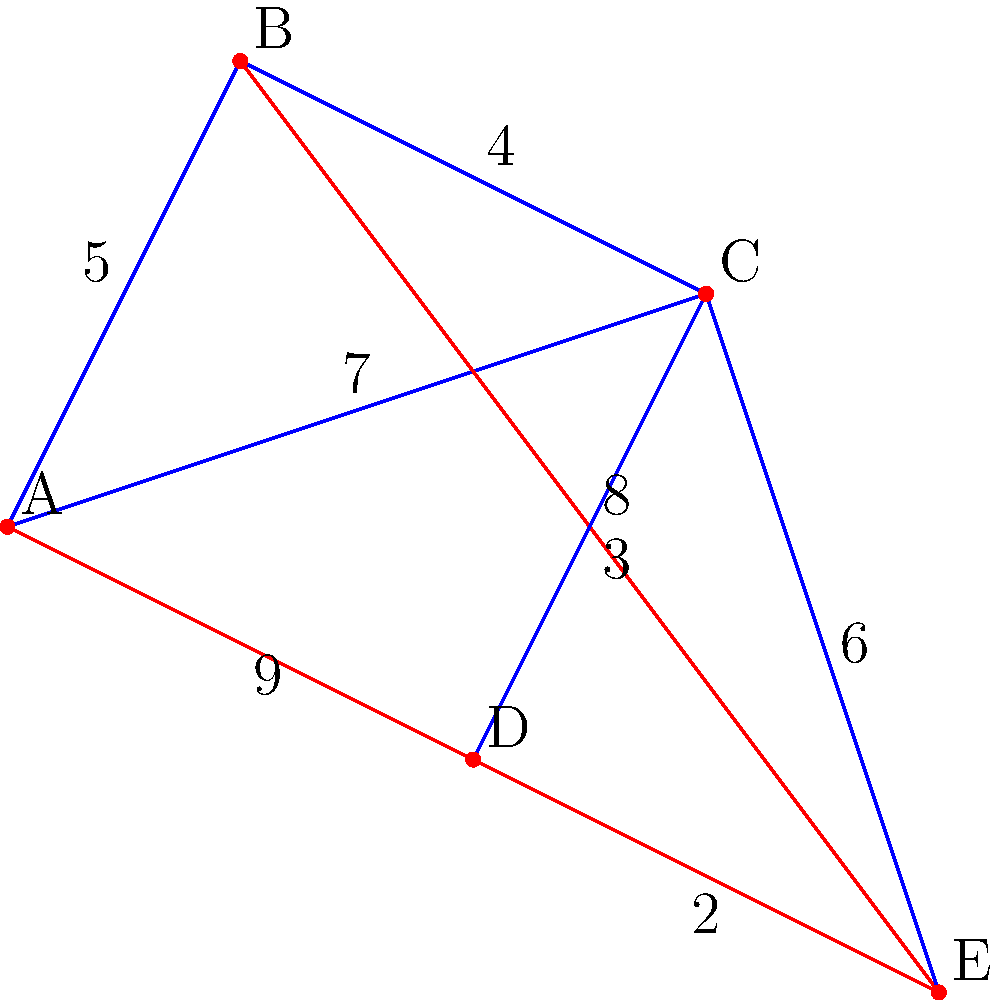In the given graph representing a hospital network, vertices represent different departments, and edges represent potential resource-sharing connections with associated costs. Using Kruskal's algorithm, determine the minimum spanning tree (MST) for optimizing resource allocation. What is the total cost of the MST? To find the minimum spanning tree using Kruskal's algorithm, we follow these steps:

1. Sort all edges by weight in ascending order:
   ED (2), CD (3), BC (4), AB (5), CE (6), AC (7), BE (8), AD (9)

2. Start with an empty set of edges and add edges in order if they don't create a cycle:
   - Add ED (2)
   - Add CD (3)
   - Add BC (4)
   - Add AB (5)

3. Stop when we have $n-1$ edges, where $n$ is the number of vertices.

The resulting minimum spanning tree consists of the edges:
1. ED (cost: 2)
2. CD (cost: 3)
3. BC (cost: 4)
4. AB (cost: 5)

To calculate the total cost, we sum the weights of these edges:
$$ \text{Total Cost} = 2 + 3 + 4 + 5 = 14 $$

Therefore, the total cost of the minimum spanning tree is 14.
Answer: 14 